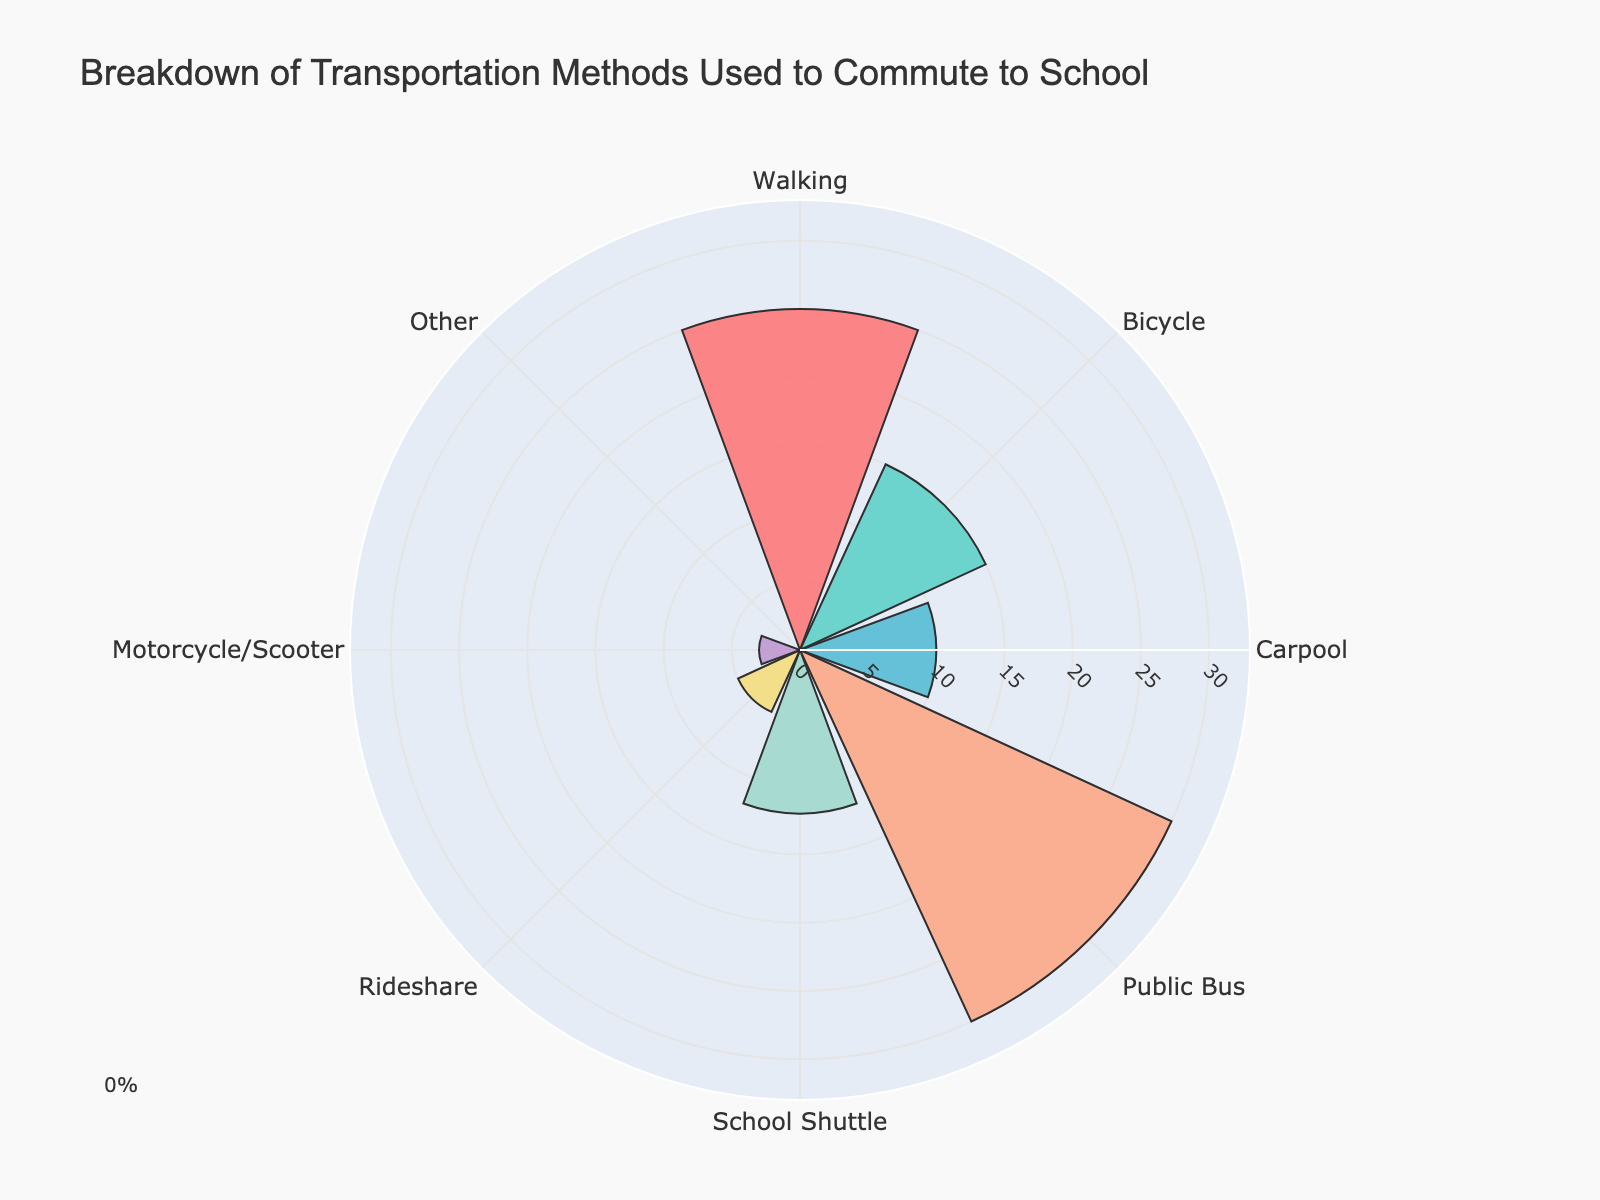What is the title of the chart? The title of the chart can be found at the top of the visual, which usually provides a summary of what the chart represents.
Answer: Breakdown of Transportation Methods Used to Commute to School What transportation method has the highest percentage? By looking at the lengths of the bars or segments, the method with the longest bar or the largest segment corresponds to the highest percentage.
Answer: Public Bus Which transportation method has the lowest percentage? By inspecting the chart for the shortest bar or smallest segment, we can identify the transportation method with the lowest percentage.
Answer: Other What percentage of students use bicycles to commute to school? Look for the segment or bar labeled "Bicycle" and note the percentage value associated with it.
Answer: 15% 